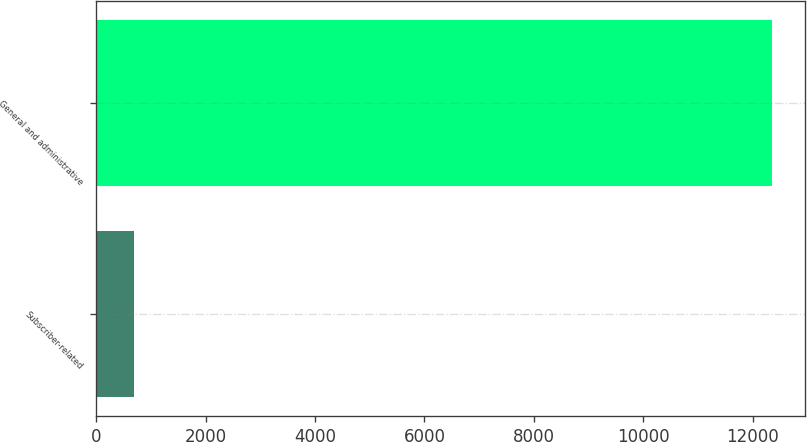Convert chart to OTSL. <chart><loc_0><loc_0><loc_500><loc_500><bar_chart><fcel>Subscriber-related<fcel>General and administrative<nl><fcel>694<fcel>12343<nl></chart> 